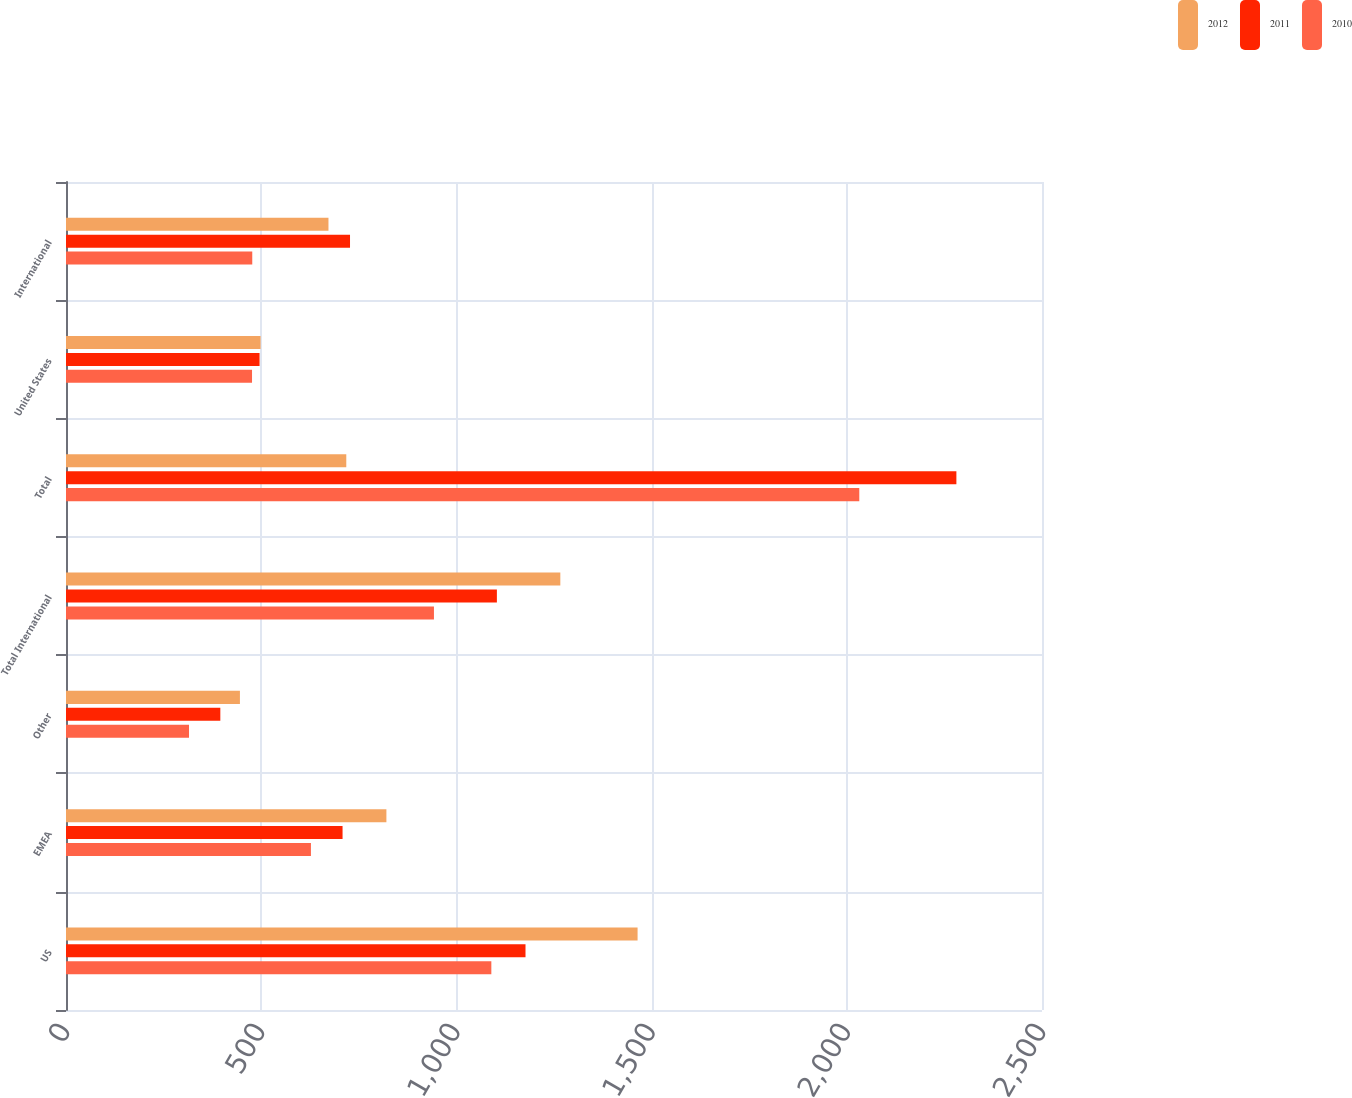Convert chart. <chart><loc_0><loc_0><loc_500><loc_500><stacked_bar_chart><ecel><fcel>US<fcel>EMEA<fcel>Other<fcel>Total International<fcel>Total<fcel>United States<fcel>International<nl><fcel>2012<fcel>1464.1<fcel>820.7<fcel>445.5<fcel>1266.2<fcel>717.95<fcel>498.4<fcel>672.3<nl><fcel>2011<fcel>1177<fcel>708.4<fcel>395.3<fcel>1103.7<fcel>2280.7<fcel>495.8<fcel>727.5<nl><fcel>2010<fcel>1089.5<fcel>627.4<fcel>315.1<fcel>942.5<fcel>2032<fcel>476.5<fcel>477.1<nl></chart> 